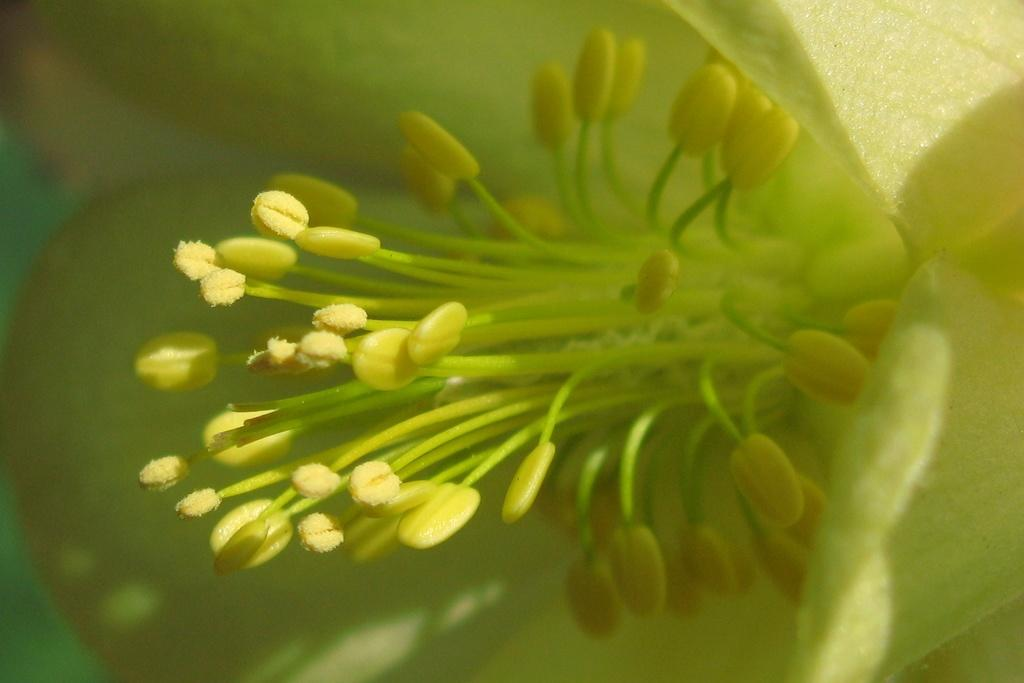What is the main subject of the image? There is a flower in the image. What type of carriage can be seen transporting the flower in the image? There is no carriage present in the image; it only features a flower. 